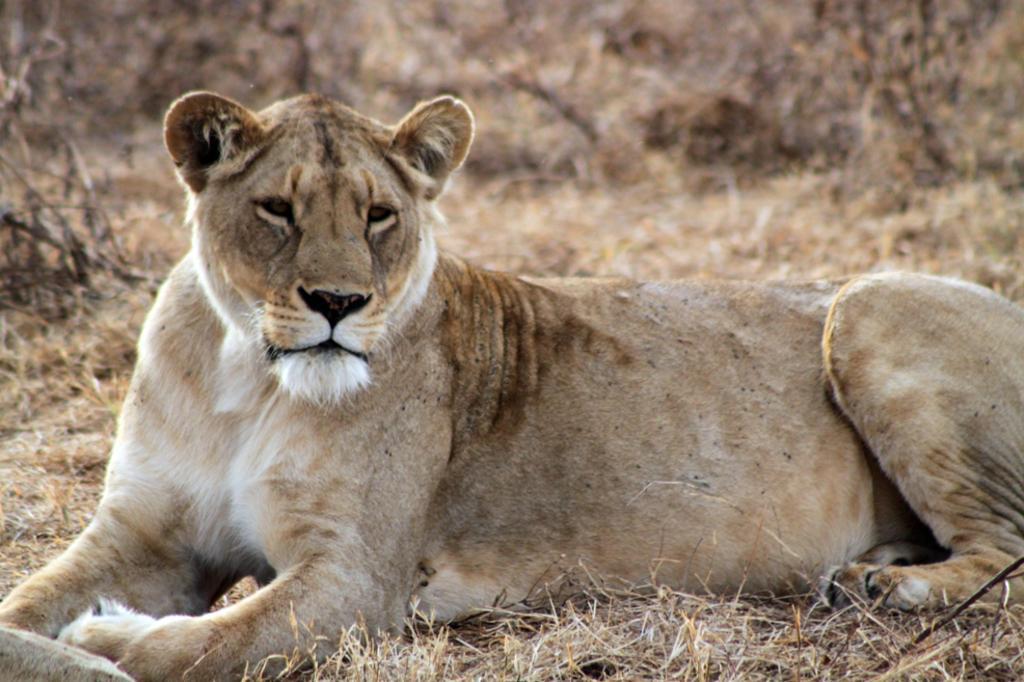Could you give a brief overview of what you see in this image? In this image we can see a lion. At the bottom of the image there is the dry grass. In the background of the image there is a blur background. 